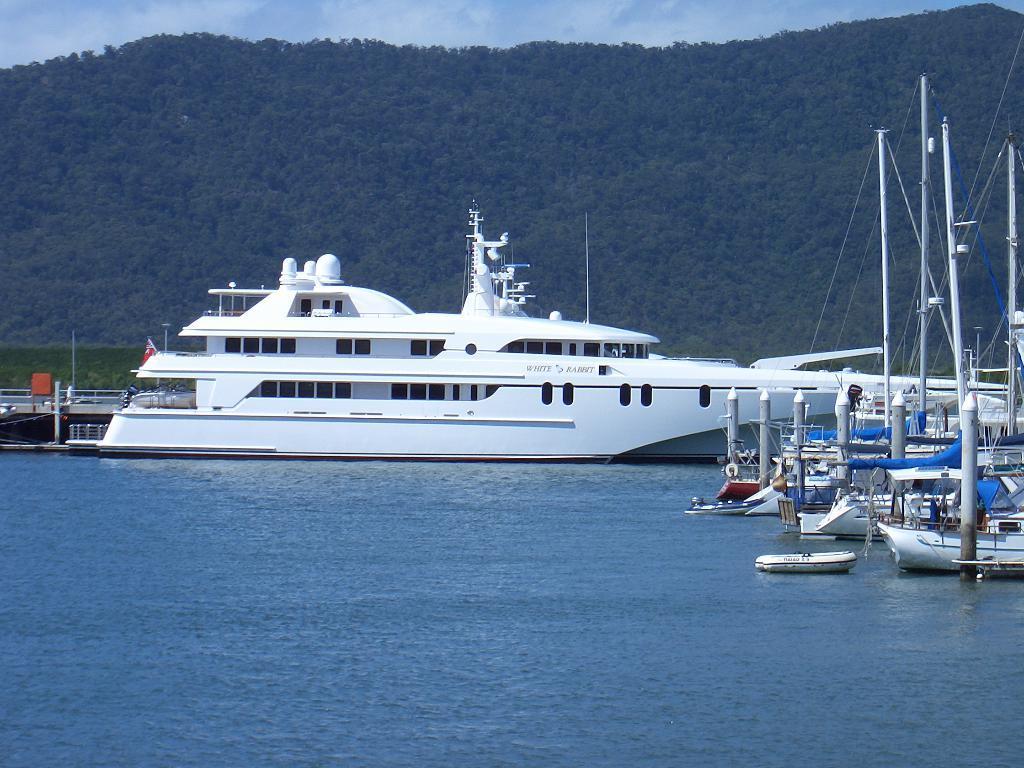How would you summarize this image in a sentence or two? In this image there are boats and ships on the water, on the left side of the image there are metal poles, behind the ship there is a metal fence, on the ship there is a flag, in the background of the image there are trees and mountains, at the top of the image there are clouds in the sky. 